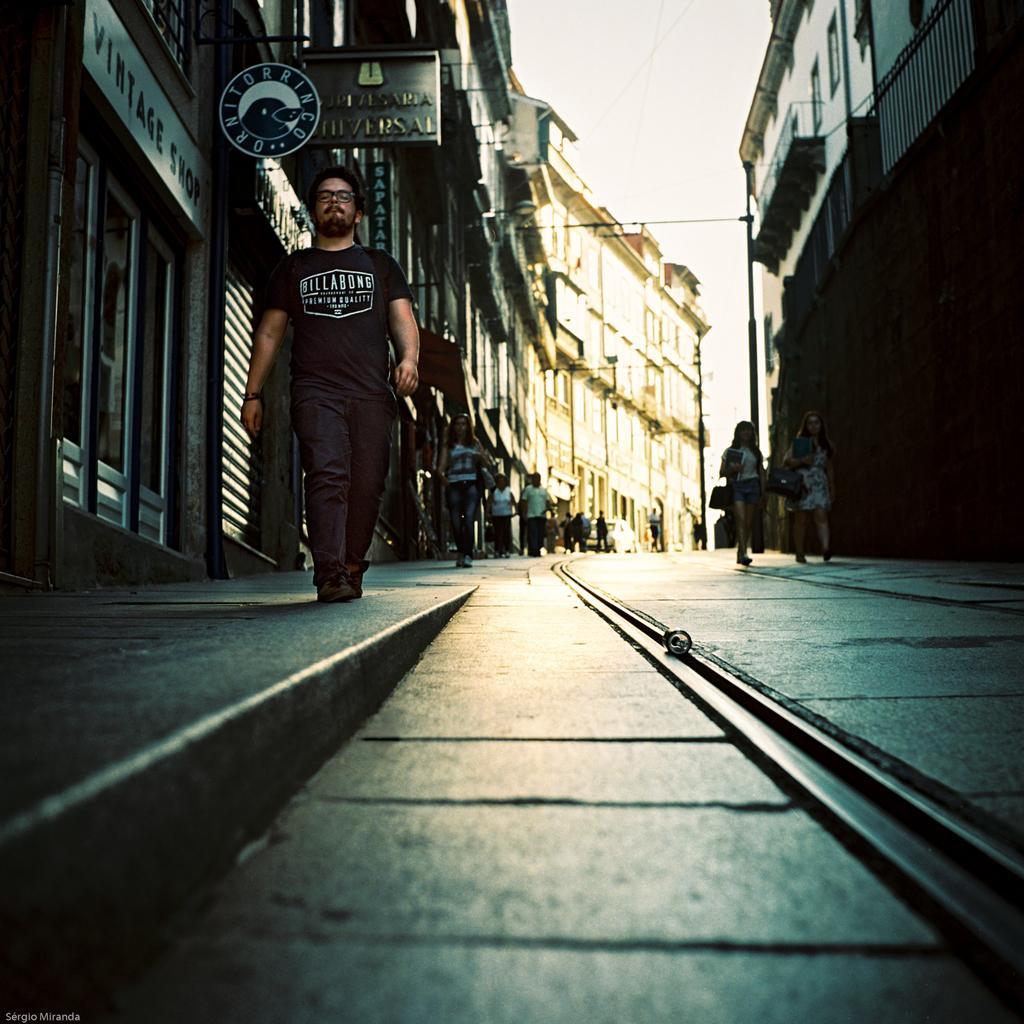How would you summarize this image in a sentence or two? In this picture we can see people on the ground, here we can see buildings, some objects and we can see sky in the background. 